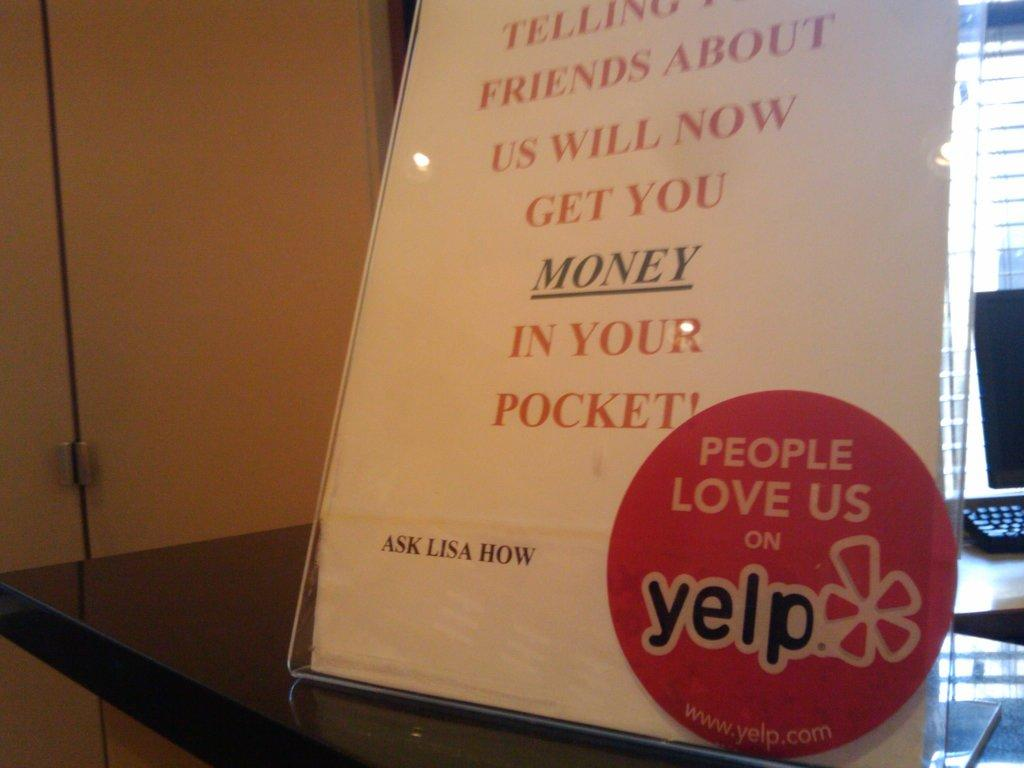<image>
Render a clear and concise summary of the photo. A flyer on a desk that says Ask Lisa How and has a Yelp sticker on it. 